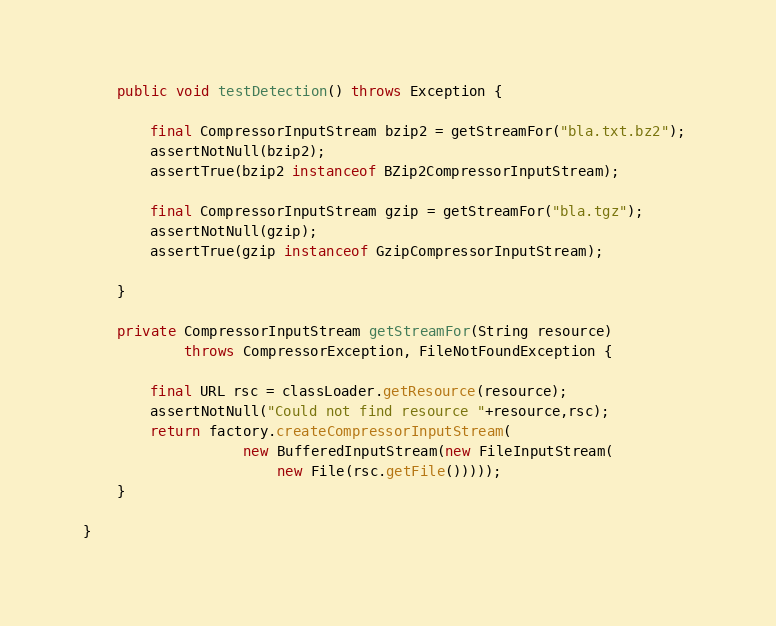Convert code to text. <code><loc_0><loc_0><loc_500><loc_500><_Java_>
    public void testDetection() throws Exception {

        final CompressorInputStream bzip2 = getStreamFor("bla.txt.bz2"); 
        assertNotNull(bzip2);
        assertTrue(bzip2 instanceof BZip2CompressorInputStream);

        final CompressorInputStream gzip = getStreamFor("bla.tgz");
        assertNotNull(gzip);
        assertTrue(gzip instanceof GzipCompressorInputStream);

    }

    private CompressorInputStream getStreamFor(String resource)
            throws CompressorException, FileNotFoundException {

        final URL rsc = classLoader.getResource(resource);
        assertNotNull("Could not find resource "+resource,rsc);
        return factory.createCompressorInputStream(
                   new BufferedInputStream(new FileInputStream(
                       new File(rsc.getFile()))));
    }

}
</code> 